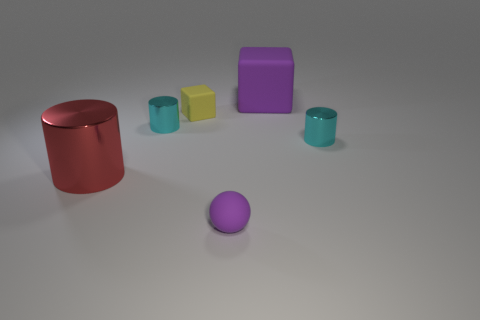Subtract all tiny cylinders. How many cylinders are left? 1 Add 3 small purple spheres. How many objects exist? 9 Subtract all brown cubes. How many cyan cylinders are left? 2 Subtract all red cylinders. How many cylinders are left? 2 Subtract all balls. How many objects are left? 5 Add 1 tiny purple spheres. How many tiny purple spheres are left? 2 Add 4 small yellow rubber cubes. How many small yellow rubber cubes exist? 5 Subtract 0 blue balls. How many objects are left? 6 Subtract all yellow cylinders. Subtract all yellow cubes. How many cylinders are left? 3 Subtract all small brown shiny blocks. Subtract all cyan things. How many objects are left? 4 